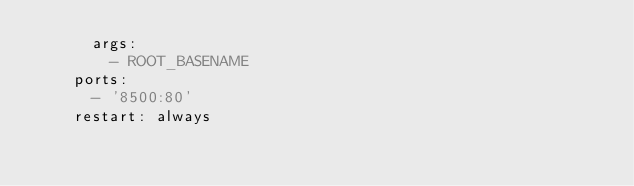<code> <loc_0><loc_0><loc_500><loc_500><_YAML_>      args:
        - ROOT_BASENAME
    ports:
      - '8500:80'
    restart: always
</code> 